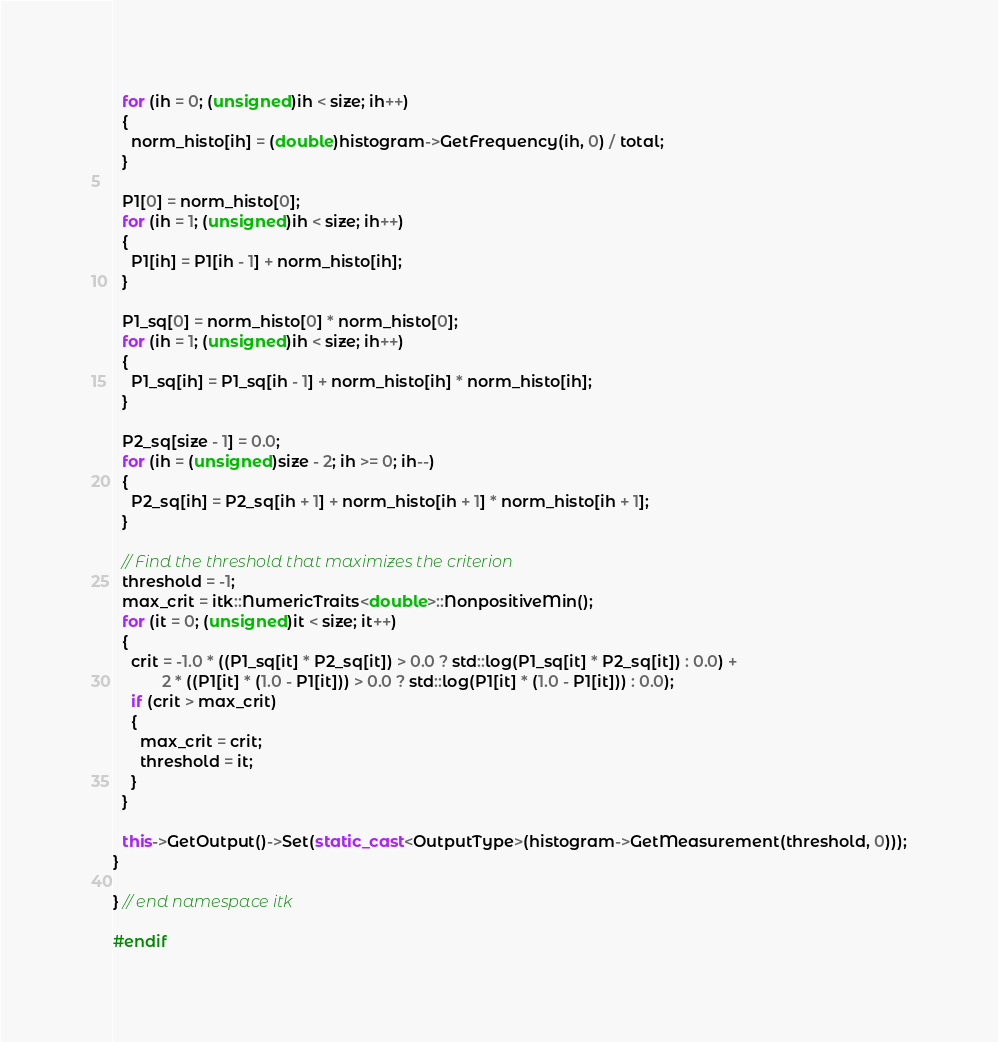Convert code to text. <code><loc_0><loc_0><loc_500><loc_500><_C++_>
  for (ih = 0; (unsigned)ih < size; ih++)
  {
    norm_histo[ih] = (double)histogram->GetFrequency(ih, 0) / total;
  }

  P1[0] = norm_histo[0];
  for (ih = 1; (unsigned)ih < size; ih++)
  {
    P1[ih] = P1[ih - 1] + norm_histo[ih];
  }

  P1_sq[0] = norm_histo[0] * norm_histo[0];
  for (ih = 1; (unsigned)ih < size; ih++)
  {
    P1_sq[ih] = P1_sq[ih - 1] + norm_histo[ih] * norm_histo[ih];
  }

  P2_sq[size - 1] = 0.0;
  for (ih = (unsigned)size - 2; ih >= 0; ih--)
  {
    P2_sq[ih] = P2_sq[ih + 1] + norm_histo[ih + 1] * norm_histo[ih + 1];
  }

  // Find the threshold that maximizes the criterion
  threshold = -1;
  max_crit = itk::NumericTraits<double>::NonpositiveMin();
  for (it = 0; (unsigned)it < size; it++)
  {
    crit = -1.0 * ((P1_sq[it] * P2_sq[it]) > 0.0 ? std::log(P1_sq[it] * P2_sq[it]) : 0.0) +
           2 * ((P1[it] * (1.0 - P1[it])) > 0.0 ? std::log(P1[it] * (1.0 - P1[it])) : 0.0);
    if (crit > max_crit)
    {
      max_crit = crit;
      threshold = it;
    }
  }

  this->GetOutput()->Set(static_cast<OutputType>(histogram->GetMeasurement(threshold, 0)));
}

} // end namespace itk

#endif
</code> 